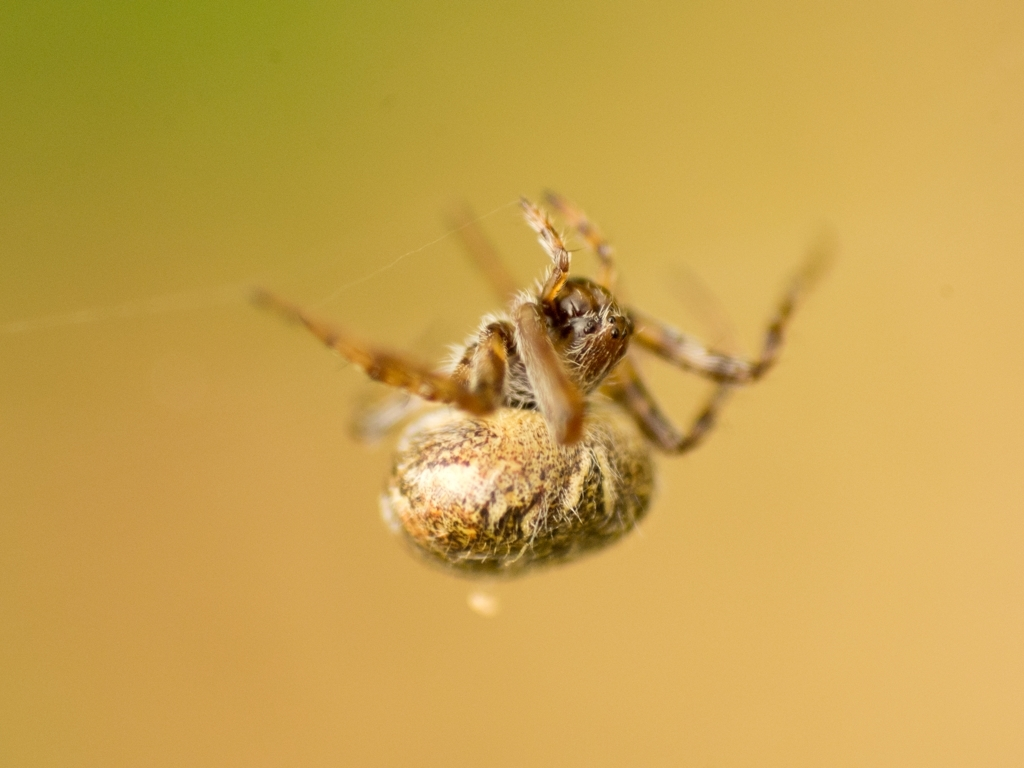What species might this spider belong to, and can you tell something about its habitat? While I cannot precisely identify the species from this image, the spider appears to be orb-weaving, common in garden areas where they spin webs to catch prey. Orb-weaver spiders are known for their wheel-shaped webs and are often found in green spaces. 